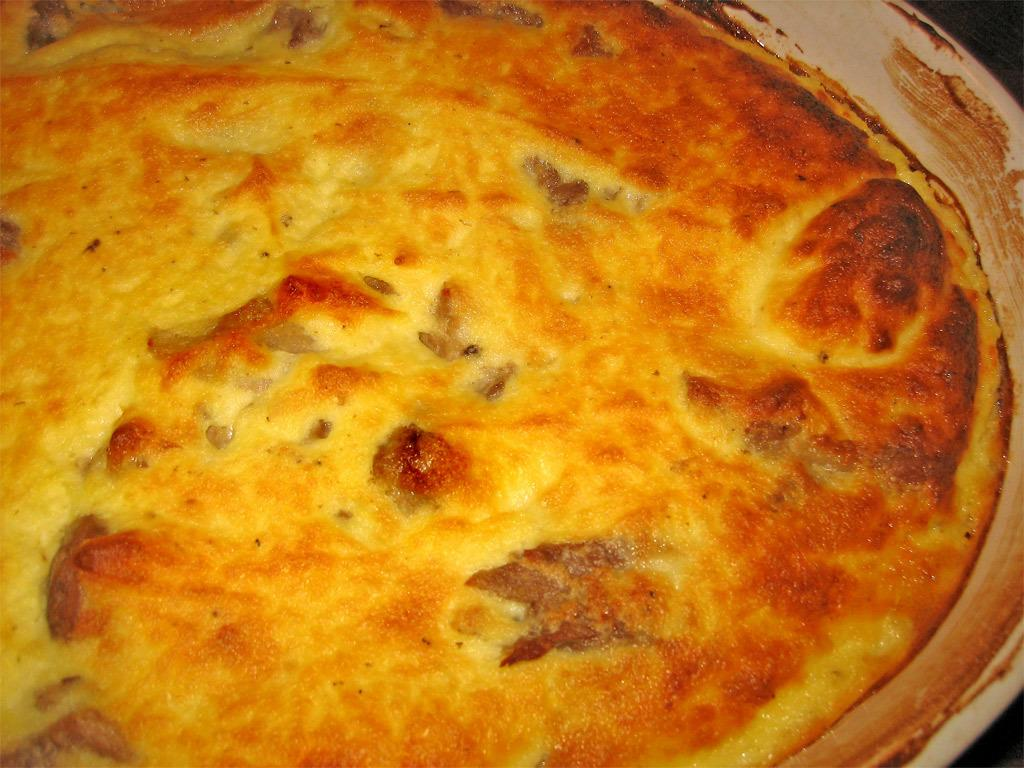What is present on the plate in the image? There is food placed in a plate in the image. What type of food can be seen on the plate? The food contains vegetables. What type of vessel is being used in the battle depicted in the image? There is no battle or vessel present in the image; it features a plate of food with vegetables. How does the temper of the person eating the food affect the taste in the image? There is no indication of the person's temper or taste in the image; it only shows a plate of food with vegetables. 